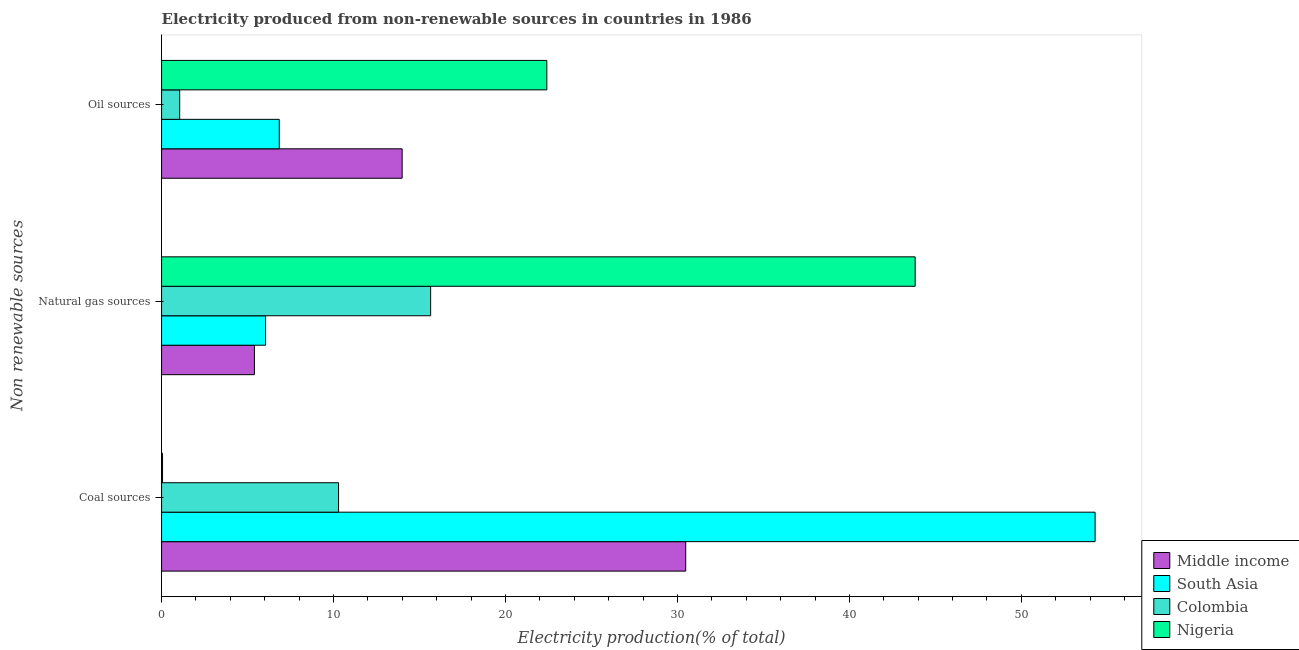Are the number of bars per tick equal to the number of legend labels?
Provide a short and direct response. Yes. What is the label of the 2nd group of bars from the top?
Your response must be concise. Natural gas sources. What is the percentage of electricity produced by coal in Nigeria?
Make the answer very short. 0.06. Across all countries, what is the maximum percentage of electricity produced by oil sources?
Offer a terse response. 22.4. Across all countries, what is the minimum percentage of electricity produced by oil sources?
Your answer should be compact. 1.05. In which country was the percentage of electricity produced by oil sources maximum?
Offer a very short reply. Nigeria. What is the total percentage of electricity produced by oil sources in the graph?
Ensure brevity in your answer.  44.29. What is the difference between the percentage of electricity produced by coal in Nigeria and that in Colombia?
Make the answer very short. -10.24. What is the difference between the percentage of electricity produced by natural gas in Middle income and the percentage of electricity produced by coal in South Asia?
Offer a very short reply. -48.89. What is the average percentage of electricity produced by oil sources per country?
Give a very brief answer. 11.07. What is the difference between the percentage of electricity produced by natural gas and percentage of electricity produced by oil sources in South Asia?
Offer a very short reply. -0.8. What is the ratio of the percentage of electricity produced by natural gas in Nigeria to that in South Asia?
Your answer should be compact. 7.25. Is the percentage of electricity produced by natural gas in Colombia less than that in South Asia?
Your answer should be compact. No. Is the difference between the percentage of electricity produced by oil sources in South Asia and Nigeria greater than the difference between the percentage of electricity produced by natural gas in South Asia and Nigeria?
Offer a terse response. Yes. What is the difference between the highest and the second highest percentage of electricity produced by coal?
Provide a short and direct response. 23.81. What is the difference between the highest and the lowest percentage of electricity produced by natural gas?
Give a very brief answer. 38.42. Is the sum of the percentage of electricity produced by coal in South Asia and Colombia greater than the maximum percentage of electricity produced by natural gas across all countries?
Offer a very short reply. Yes. What does the 1st bar from the top in Coal sources represents?
Your response must be concise. Nigeria. What does the 1st bar from the bottom in Natural gas sources represents?
Your answer should be very brief. Middle income. Is it the case that in every country, the sum of the percentage of electricity produced by coal and percentage of electricity produced by natural gas is greater than the percentage of electricity produced by oil sources?
Ensure brevity in your answer.  Yes. How many bars are there?
Ensure brevity in your answer.  12. Are all the bars in the graph horizontal?
Your answer should be very brief. Yes. What is the difference between two consecutive major ticks on the X-axis?
Give a very brief answer. 10. Does the graph contain any zero values?
Your answer should be compact. No. Does the graph contain grids?
Offer a very short reply. No. Where does the legend appear in the graph?
Ensure brevity in your answer.  Bottom right. What is the title of the graph?
Provide a short and direct response. Electricity produced from non-renewable sources in countries in 1986. What is the label or title of the X-axis?
Ensure brevity in your answer.  Electricity production(% of total). What is the label or title of the Y-axis?
Offer a terse response. Non renewable sources. What is the Electricity production(% of total) of Middle income in Coal sources?
Your answer should be very brief. 30.48. What is the Electricity production(% of total) in South Asia in Coal sources?
Ensure brevity in your answer.  54.29. What is the Electricity production(% of total) of Colombia in Coal sources?
Give a very brief answer. 10.29. What is the Electricity production(% of total) in Nigeria in Coal sources?
Offer a very short reply. 0.06. What is the Electricity production(% of total) in Middle income in Natural gas sources?
Make the answer very short. 5.4. What is the Electricity production(% of total) of South Asia in Natural gas sources?
Your response must be concise. 6.05. What is the Electricity production(% of total) in Colombia in Natural gas sources?
Your answer should be very brief. 15.65. What is the Electricity production(% of total) of Nigeria in Natural gas sources?
Ensure brevity in your answer.  43.82. What is the Electricity production(% of total) in Middle income in Oil sources?
Offer a terse response. 13.99. What is the Electricity production(% of total) of South Asia in Oil sources?
Provide a succinct answer. 6.84. What is the Electricity production(% of total) in Colombia in Oil sources?
Your answer should be very brief. 1.05. What is the Electricity production(% of total) of Nigeria in Oil sources?
Your answer should be very brief. 22.4. Across all Non renewable sources, what is the maximum Electricity production(% of total) in Middle income?
Make the answer very short. 30.48. Across all Non renewable sources, what is the maximum Electricity production(% of total) in South Asia?
Give a very brief answer. 54.29. Across all Non renewable sources, what is the maximum Electricity production(% of total) of Colombia?
Your response must be concise. 15.65. Across all Non renewable sources, what is the maximum Electricity production(% of total) of Nigeria?
Provide a succinct answer. 43.82. Across all Non renewable sources, what is the minimum Electricity production(% of total) of Middle income?
Give a very brief answer. 5.4. Across all Non renewable sources, what is the minimum Electricity production(% of total) of South Asia?
Offer a very short reply. 6.05. Across all Non renewable sources, what is the minimum Electricity production(% of total) of Colombia?
Your answer should be very brief. 1.05. Across all Non renewable sources, what is the minimum Electricity production(% of total) of Nigeria?
Keep it short and to the point. 0.06. What is the total Electricity production(% of total) of Middle income in the graph?
Ensure brevity in your answer.  49.87. What is the total Electricity production(% of total) in South Asia in the graph?
Offer a very short reply. 67.18. What is the total Electricity production(% of total) of Colombia in the graph?
Keep it short and to the point. 26.99. What is the total Electricity production(% of total) of Nigeria in the graph?
Your answer should be very brief. 66.28. What is the difference between the Electricity production(% of total) of Middle income in Coal sources and that in Natural gas sources?
Provide a succinct answer. 25.08. What is the difference between the Electricity production(% of total) in South Asia in Coal sources and that in Natural gas sources?
Provide a succinct answer. 48.24. What is the difference between the Electricity production(% of total) in Colombia in Coal sources and that in Natural gas sources?
Provide a succinct answer. -5.36. What is the difference between the Electricity production(% of total) in Nigeria in Coal sources and that in Natural gas sources?
Give a very brief answer. -43.77. What is the difference between the Electricity production(% of total) of Middle income in Coal sources and that in Oil sources?
Ensure brevity in your answer.  16.49. What is the difference between the Electricity production(% of total) in South Asia in Coal sources and that in Oil sources?
Offer a terse response. 47.44. What is the difference between the Electricity production(% of total) in Colombia in Coal sources and that in Oil sources?
Your answer should be compact. 9.24. What is the difference between the Electricity production(% of total) in Nigeria in Coal sources and that in Oil sources?
Ensure brevity in your answer.  -22.35. What is the difference between the Electricity production(% of total) in Middle income in Natural gas sources and that in Oil sources?
Your answer should be compact. -8.59. What is the difference between the Electricity production(% of total) in South Asia in Natural gas sources and that in Oil sources?
Offer a terse response. -0.8. What is the difference between the Electricity production(% of total) in Colombia in Natural gas sources and that in Oil sources?
Offer a very short reply. 14.59. What is the difference between the Electricity production(% of total) of Nigeria in Natural gas sources and that in Oil sources?
Your answer should be compact. 21.42. What is the difference between the Electricity production(% of total) of Middle income in Coal sources and the Electricity production(% of total) of South Asia in Natural gas sources?
Make the answer very short. 24.43. What is the difference between the Electricity production(% of total) in Middle income in Coal sources and the Electricity production(% of total) in Colombia in Natural gas sources?
Your answer should be compact. 14.83. What is the difference between the Electricity production(% of total) of Middle income in Coal sources and the Electricity production(% of total) of Nigeria in Natural gas sources?
Offer a very short reply. -13.34. What is the difference between the Electricity production(% of total) of South Asia in Coal sources and the Electricity production(% of total) of Colombia in Natural gas sources?
Your answer should be compact. 38.64. What is the difference between the Electricity production(% of total) in South Asia in Coal sources and the Electricity production(% of total) in Nigeria in Natural gas sources?
Give a very brief answer. 10.46. What is the difference between the Electricity production(% of total) of Colombia in Coal sources and the Electricity production(% of total) of Nigeria in Natural gas sources?
Offer a terse response. -33.53. What is the difference between the Electricity production(% of total) in Middle income in Coal sources and the Electricity production(% of total) in South Asia in Oil sources?
Your answer should be compact. 23.64. What is the difference between the Electricity production(% of total) of Middle income in Coal sources and the Electricity production(% of total) of Colombia in Oil sources?
Give a very brief answer. 29.43. What is the difference between the Electricity production(% of total) of Middle income in Coal sources and the Electricity production(% of total) of Nigeria in Oil sources?
Your answer should be compact. 8.08. What is the difference between the Electricity production(% of total) in South Asia in Coal sources and the Electricity production(% of total) in Colombia in Oil sources?
Make the answer very short. 53.23. What is the difference between the Electricity production(% of total) of South Asia in Coal sources and the Electricity production(% of total) of Nigeria in Oil sources?
Offer a very short reply. 31.88. What is the difference between the Electricity production(% of total) in Colombia in Coal sources and the Electricity production(% of total) in Nigeria in Oil sources?
Give a very brief answer. -12.11. What is the difference between the Electricity production(% of total) in Middle income in Natural gas sources and the Electricity production(% of total) in South Asia in Oil sources?
Offer a terse response. -1.45. What is the difference between the Electricity production(% of total) in Middle income in Natural gas sources and the Electricity production(% of total) in Colombia in Oil sources?
Make the answer very short. 4.35. What is the difference between the Electricity production(% of total) in Middle income in Natural gas sources and the Electricity production(% of total) in Nigeria in Oil sources?
Give a very brief answer. -17.01. What is the difference between the Electricity production(% of total) in South Asia in Natural gas sources and the Electricity production(% of total) in Colombia in Oil sources?
Ensure brevity in your answer.  4.99. What is the difference between the Electricity production(% of total) of South Asia in Natural gas sources and the Electricity production(% of total) of Nigeria in Oil sources?
Your answer should be very brief. -16.36. What is the difference between the Electricity production(% of total) of Colombia in Natural gas sources and the Electricity production(% of total) of Nigeria in Oil sources?
Keep it short and to the point. -6.76. What is the average Electricity production(% of total) of Middle income per Non renewable sources?
Your response must be concise. 16.62. What is the average Electricity production(% of total) in South Asia per Non renewable sources?
Offer a very short reply. 22.39. What is the average Electricity production(% of total) of Colombia per Non renewable sources?
Ensure brevity in your answer.  9. What is the average Electricity production(% of total) of Nigeria per Non renewable sources?
Your answer should be compact. 22.09. What is the difference between the Electricity production(% of total) in Middle income and Electricity production(% of total) in South Asia in Coal sources?
Provide a short and direct response. -23.81. What is the difference between the Electricity production(% of total) in Middle income and Electricity production(% of total) in Colombia in Coal sources?
Provide a succinct answer. 20.19. What is the difference between the Electricity production(% of total) of Middle income and Electricity production(% of total) of Nigeria in Coal sources?
Make the answer very short. 30.42. What is the difference between the Electricity production(% of total) of South Asia and Electricity production(% of total) of Colombia in Coal sources?
Keep it short and to the point. 43.99. What is the difference between the Electricity production(% of total) of South Asia and Electricity production(% of total) of Nigeria in Coal sources?
Provide a short and direct response. 54.23. What is the difference between the Electricity production(% of total) of Colombia and Electricity production(% of total) of Nigeria in Coal sources?
Offer a terse response. 10.24. What is the difference between the Electricity production(% of total) of Middle income and Electricity production(% of total) of South Asia in Natural gas sources?
Keep it short and to the point. -0.65. What is the difference between the Electricity production(% of total) in Middle income and Electricity production(% of total) in Colombia in Natural gas sources?
Keep it short and to the point. -10.25. What is the difference between the Electricity production(% of total) in Middle income and Electricity production(% of total) in Nigeria in Natural gas sources?
Make the answer very short. -38.42. What is the difference between the Electricity production(% of total) of South Asia and Electricity production(% of total) of Colombia in Natural gas sources?
Make the answer very short. -9.6. What is the difference between the Electricity production(% of total) of South Asia and Electricity production(% of total) of Nigeria in Natural gas sources?
Give a very brief answer. -37.78. What is the difference between the Electricity production(% of total) of Colombia and Electricity production(% of total) of Nigeria in Natural gas sources?
Your answer should be very brief. -28.18. What is the difference between the Electricity production(% of total) of Middle income and Electricity production(% of total) of South Asia in Oil sources?
Provide a short and direct response. 7.15. What is the difference between the Electricity production(% of total) in Middle income and Electricity production(% of total) in Colombia in Oil sources?
Your response must be concise. 12.94. What is the difference between the Electricity production(% of total) of Middle income and Electricity production(% of total) of Nigeria in Oil sources?
Provide a short and direct response. -8.41. What is the difference between the Electricity production(% of total) of South Asia and Electricity production(% of total) of Colombia in Oil sources?
Keep it short and to the point. 5.79. What is the difference between the Electricity production(% of total) in South Asia and Electricity production(% of total) in Nigeria in Oil sources?
Provide a succinct answer. -15.56. What is the difference between the Electricity production(% of total) in Colombia and Electricity production(% of total) in Nigeria in Oil sources?
Offer a terse response. -21.35. What is the ratio of the Electricity production(% of total) of Middle income in Coal sources to that in Natural gas sources?
Offer a very short reply. 5.65. What is the ratio of the Electricity production(% of total) of South Asia in Coal sources to that in Natural gas sources?
Your answer should be compact. 8.98. What is the ratio of the Electricity production(% of total) of Colombia in Coal sources to that in Natural gas sources?
Provide a short and direct response. 0.66. What is the ratio of the Electricity production(% of total) in Nigeria in Coal sources to that in Natural gas sources?
Offer a terse response. 0. What is the ratio of the Electricity production(% of total) of Middle income in Coal sources to that in Oil sources?
Provide a short and direct response. 2.18. What is the ratio of the Electricity production(% of total) in South Asia in Coal sources to that in Oil sources?
Give a very brief answer. 7.93. What is the ratio of the Electricity production(% of total) of Colombia in Coal sources to that in Oil sources?
Provide a succinct answer. 9.77. What is the ratio of the Electricity production(% of total) of Nigeria in Coal sources to that in Oil sources?
Your answer should be compact. 0. What is the ratio of the Electricity production(% of total) in Middle income in Natural gas sources to that in Oil sources?
Offer a terse response. 0.39. What is the ratio of the Electricity production(% of total) in South Asia in Natural gas sources to that in Oil sources?
Your response must be concise. 0.88. What is the ratio of the Electricity production(% of total) in Colombia in Natural gas sources to that in Oil sources?
Provide a short and direct response. 14.85. What is the ratio of the Electricity production(% of total) of Nigeria in Natural gas sources to that in Oil sources?
Provide a succinct answer. 1.96. What is the difference between the highest and the second highest Electricity production(% of total) of Middle income?
Keep it short and to the point. 16.49. What is the difference between the highest and the second highest Electricity production(% of total) of South Asia?
Your response must be concise. 47.44. What is the difference between the highest and the second highest Electricity production(% of total) of Colombia?
Ensure brevity in your answer.  5.36. What is the difference between the highest and the second highest Electricity production(% of total) in Nigeria?
Give a very brief answer. 21.42. What is the difference between the highest and the lowest Electricity production(% of total) in Middle income?
Offer a terse response. 25.08. What is the difference between the highest and the lowest Electricity production(% of total) of South Asia?
Offer a very short reply. 48.24. What is the difference between the highest and the lowest Electricity production(% of total) of Colombia?
Provide a succinct answer. 14.59. What is the difference between the highest and the lowest Electricity production(% of total) of Nigeria?
Your answer should be very brief. 43.77. 